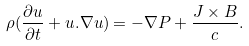<formula> <loc_0><loc_0><loc_500><loc_500>\rho ( \frac { \partial { u } } { \partial t } + { u } . \nabla { u } ) = - \nabla P + \frac { { J } \times { B } } { c } .</formula> 